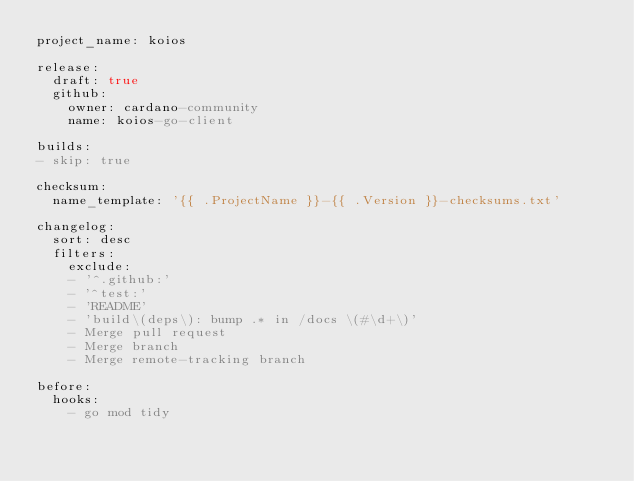Convert code to text. <code><loc_0><loc_0><loc_500><loc_500><_YAML_>project_name: koios

release:
  draft: true
  github:
    owner: cardano-community
    name: koios-go-client

builds:
- skip: true

checksum:
  name_template: '{{ .ProjectName }}-{{ .Version }}-checksums.txt'

changelog:
  sort: desc
  filters:
    exclude:
    - '^.github:'
    - '^test:'
    - 'README'
    - 'build\(deps\): bump .* in /docs \(#\d+\)'
    - Merge pull request
    - Merge branch
    - Merge remote-tracking branch

before:
  hooks:
    - go mod tidy

</code> 